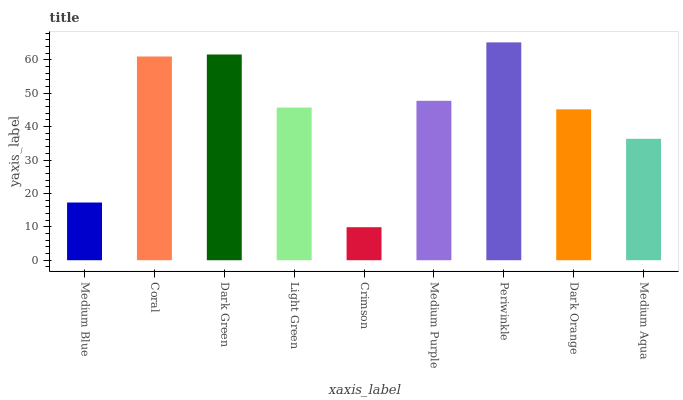Is Crimson the minimum?
Answer yes or no. Yes. Is Periwinkle the maximum?
Answer yes or no. Yes. Is Coral the minimum?
Answer yes or no. No. Is Coral the maximum?
Answer yes or no. No. Is Coral greater than Medium Blue?
Answer yes or no. Yes. Is Medium Blue less than Coral?
Answer yes or no. Yes. Is Medium Blue greater than Coral?
Answer yes or no. No. Is Coral less than Medium Blue?
Answer yes or no. No. Is Light Green the high median?
Answer yes or no. Yes. Is Light Green the low median?
Answer yes or no. Yes. Is Dark Green the high median?
Answer yes or no. No. Is Crimson the low median?
Answer yes or no. No. 